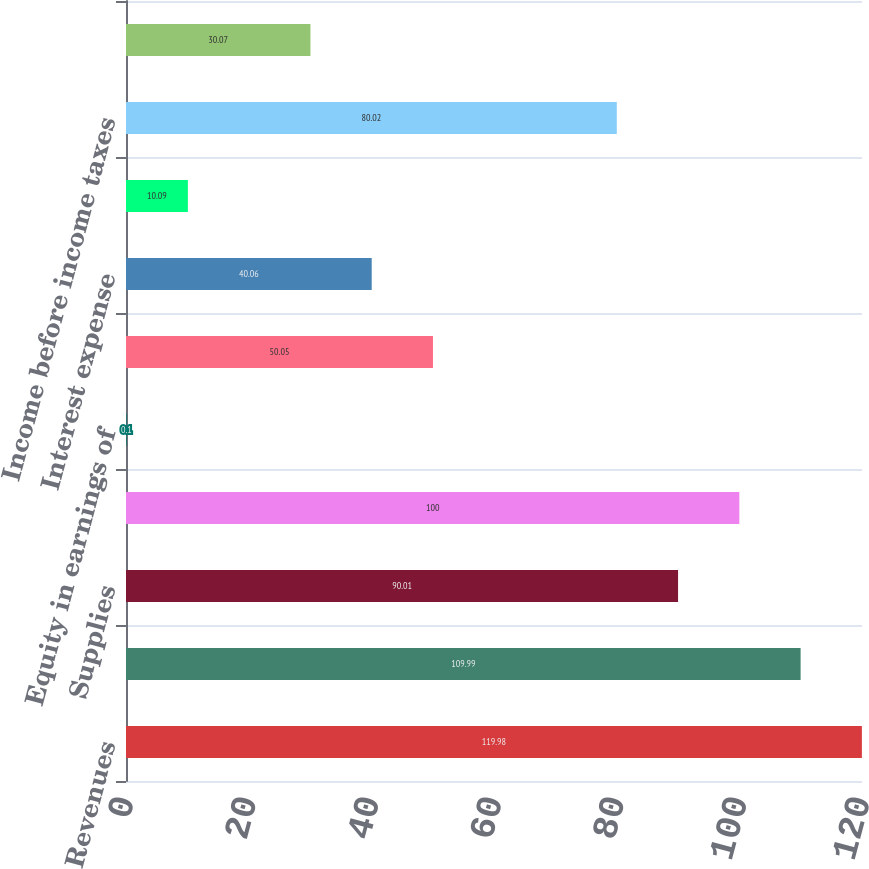<chart> <loc_0><loc_0><loc_500><loc_500><bar_chart><fcel>Revenues<fcel>Salaries and benefits<fcel>Supplies<fcel>Other operating expenses<fcel>Equity in earnings of<fcel>Depreciation and amortization<fcel>Interest expense<fcel>Legal claim costs (benefits)<fcel>Income before income taxes<fcel>Provision for income taxes<nl><fcel>119.98<fcel>109.99<fcel>90.01<fcel>100<fcel>0.1<fcel>50.05<fcel>40.06<fcel>10.09<fcel>80.02<fcel>30.07<nl></chart> 